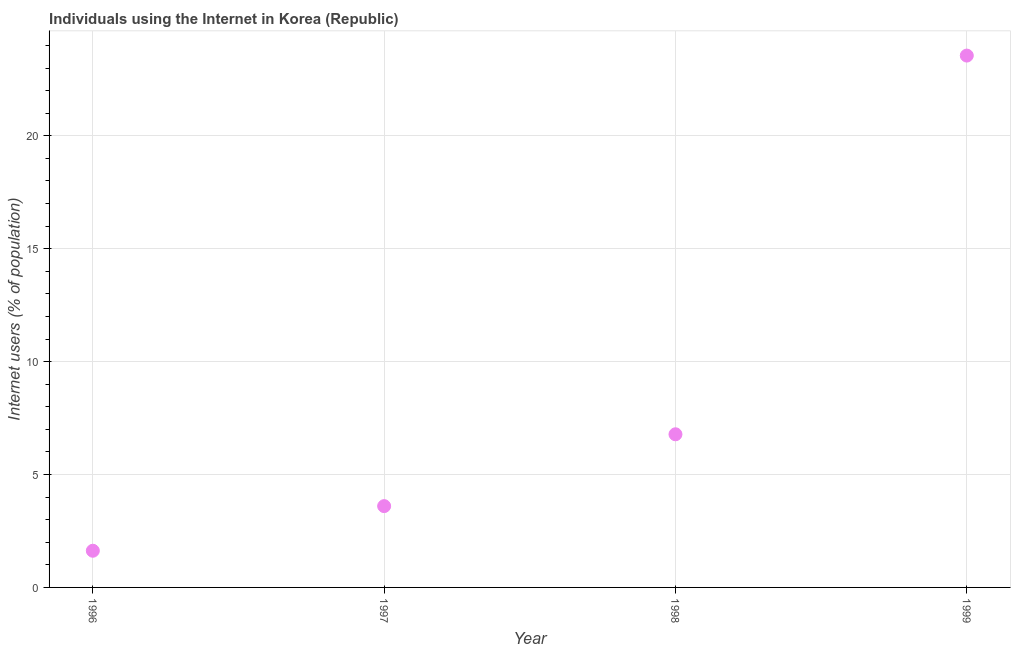What is the number of internet users in 1999?
Provide a short and direct response. 23.55. Across all years, what is the maximum number of internet users?
Offer a terse response. 23.55. Across all years, what is the minimum number of internet users?
Make the answer very short. 1.62. What is the sum of the number of internet users?
Provide a succinct answer. 35.56. What is the difference between the number of internet users in 1997 and 1998?
Offer a terse response. -3.18. What is the average number of internet users per year?
Your answer should be compact. 8.89. What is the median number of internet users?
Provide a succinct answer. 5.19. In how many years, is the number of internet users greater than 13 %?
Provide a succinct answer. 1. Do a majority of the years between 1999 and 1997 (inclusive) have number of internet users greater than 15 %?
Your answer should be compact. No. What is the ratio of the number of internet users in 1997 to that in 1998?
Your answer should be very brief. 0.53. What is the difference between the highest and the second highest number of internet users?
Offer a very short reply. 16.77. Is the sum of the number of internet users in 1997 and 1998 greater than the maximum number of internet users across all years?
Offer a very short reply. No. What is the difference between the highest and the lowest number of internet users?
Make the answer very short. 21.93. Does the number of internet users monotonically increase over the years?
Your answer should be very brief. Yes. How many dotlines are there?
Keep it short and to the point. 1. What is the difference between two consecutive major ticks on the Y-axis?
Keep it short and to the point. 5. Are the values on the major ticks of Y-axis written in scientific E-notation?
Make the answer very short. No. Does the graph contain any zero values?
Your response must be concise. No. What is the title of the graph?
Your response must be concise. Individuals using the Internet in Korea (Republic). What is the label or title of the Y-axis?
Your answer should be very brief. Internet users (% of population). What is the Internet users (% of population) in 1996?
Keep it short and to the point. 1.62. What is the Internet users (% of population) in 1997?
Make the answer very short. 3.6. What is the Internet users (% of population) in 1998?
Provide a short and direct response. 6.78. What is the Internet users (% of population) in 1999?
Offer a terse response. 23.55. What is the difference between the Internet users (% of population) in 1996 and 1997?
Offer a terse response. -1.98. What is the difference between the Internet users (% of population) in 1996 and 1998?
Your answer should be compact. -5.16. What is the difference between the Internet users (% of population) in 1996 and 1999?
Give a very brief answer. -21.93. What is the difference between the Internet users (% of population) in 1997 and 1998?
Provide a short and direct response. -3.18. What is the difference between the Internet users (% of population) in 1997 and 1999?
Give a very brief answer. -19.95. What is the difference between the Internet users (% of population) in 1998 and 1999?
Offer a terse response. -16.77. What is the ratio of the Internet users (% of population) in 1996 to that in 1997?
Ensure brevity in your answer.  0.45. What is the ratio of the Internet users (% of population) in 1996 to that in 1998?
Offer a very short reply. 0.24. What is the ratio of the Internet users (% of population) in 1996 to that in 1999?
Provide a succinct answer. 0.07. What is the ratio of the Internet users (% of population) in 1997 to that in 1998?
Ensure brevity in your answer.  0.53. What is the ratio of the Internet users (% of population) in 1997 to that in 1999?
Offer a terse response. 0.15. What is the ratio of the Internet users (% of population) in 1998 to that in 1999?
Your answer should be compact. 0.29. 